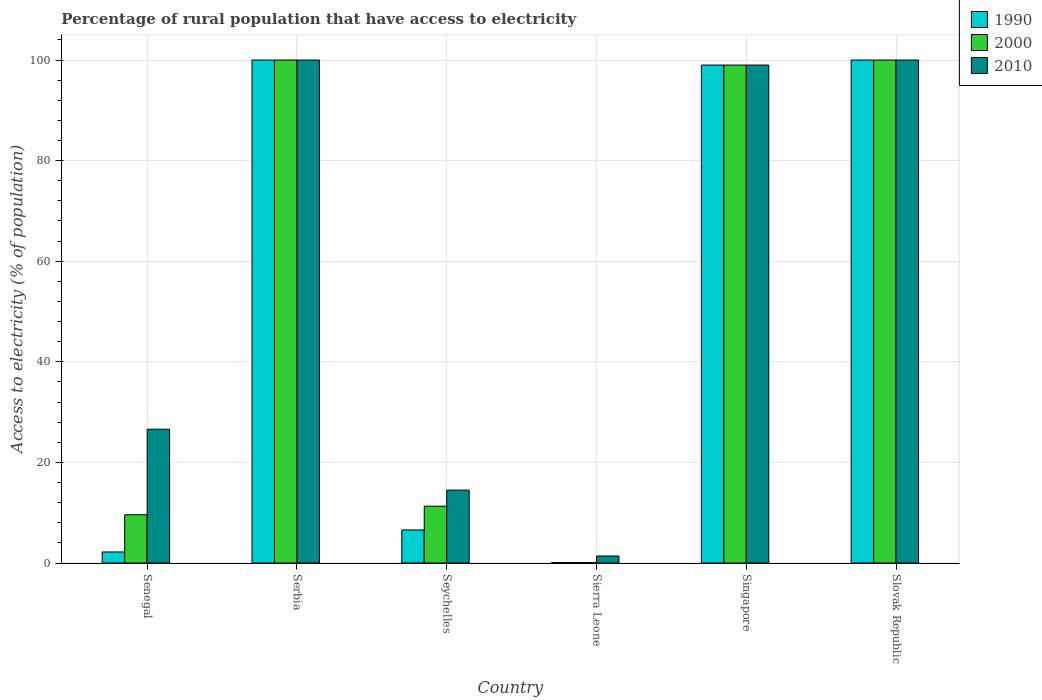How many different coloured bars are there?
Give a very brief answer. 3. What is the label of the 5th group of bars from the left?
Keep it short and to the point. Singapore. In how many cases, is the number of bars for a given country not equal to the number of legend labels?
Ensure brevity in your answer.  0. Across all countries, what is the maximum percentage of rural population that have access to electricity in 1990?
Offer a terse response. 100. In which country was the percentage of rural population that have access to electricity in 2000 maximum?
Provide a succinct answer. Serbia. In which country was the percentage of rural population that have access to electricity in 2010 minimum?
Make the answer very short. Sierra Leone. What is the total percentage of rural population that have access to electricity in 2010 in the graph?
Your answer should be very brief. 341.5. What is the difference between the percentage of rural population that have access to electricity in 2000 in Sierra Leone and that in Singapore?
Your answer should be very brief. -98.9. What is the difference between the percentage of rural population that have access to electricity in 2010 in Sierra Leone and the percentage of rural population that have access to electricity in 2000 in Singapore?
Your answer should be compact. -97.6. What is the average percentage of rural population that have access to electricity in 2000 per country?
Your answer should be compact. 53.33. What is the difference between the percentage of rural population that have access to electricity of/in 2000 and percentage of rural population that have access to electricity of/in 1990 in Senegal?
Keep it short and to the point. 7.4. What is the ratio of the percentage of rural population that have access to electricity in 2010 in Serbia to that in Sierra Leone?
Ensure brevity in your answer.  71.43. What is the difference between the highest and the lowest percentage of rural population that have access to electricity in 2010?
Provide a succinct answer. 98.6. Is the sum of the percentage of rural population that have access to electricity in 2010 in Seychelles and Slovak Republic greater than the maximum percentage of rural population that have access to electricity in 1990 across all countries?
Offer a very short reply. Yes. What does the 3rd bar from the right in Serbia represents?
Give a very brief answer. 1990. Are all the bars in the graph horizontal?
Make the answer very short. No. What is the difference between two consecutive major ticks on the Y-axis?
Offer a very short reply. 20. Does the graph contain any zero values?
Make the answer very short. No. Does the graph contain grids?
Offer a very short reply. Yes. How many legend labels are there?
Offer a terse response. 3. What is the title of the graph?
Make the answer very short. Percentage of rural population that have access to electricity. Does "1960" appear as one of the legend labels in the graph?
Ensure brevity in your answer.  No. What is the label or title of the Y-axis?
Provide a succinct answer. Access to electricity (% of population). What is the Access to electricity (% of population) in 2010 in Senegal?
Offer a very short reply. 26.6. What is the Access to electricity (% of population) in 2000 in Serbia?
Keep it short and to the point. 100. What is the Access to electricity (% of population) in 1990 in Seychelles?
Provide a short and direct response. 6.58. What is the Access to electricity (% of population) in 2000 in Seychelles?
Your response must be concise. 11.3. What is the Access to electricity (% of population) in 2010 in Seychelles?
Make the answer very short. 14.5. What is the Access to electricity (% of population) in 2000 in Sierra Leone?
Offer a terse response. 0.1. What is the Access to electricity (% of population) of 1990 in Singapore?
Offer a terse response. 99. What is the Access to electricity (% of population) of 2010 in Singapore?
Your response must be concise. 99. What is the Access to electricity (% of population) in 1990 in Slovak Republic?
Your response must be concise. 100. What is the Access to electricity (% of population) of 2000 in Slovak Republic?
Give a very brief answer. 100. Across all countries, what is the minimum Access to electricity (% of population) in 2000?
Ensure brevity in your answer.  0.1. Across all countries, what is the minimum Access to electricity (% of population) of 2010?
Your answer should be compact. 1.4. What is the total Access to electricity (% of population) in 1990 in the graph?
Make the answer very short. 307.88. What is the total Access to electricity (% of population) of 2000 in the graph?
Offer a terse response. 320. What is the total Access to electricity (% of population) of 2010 in the graph?
Keep it short and to the point. 341.5. What is the difference between the Access to electricity (% of population) of 1990 in Senegal and that in Serbia?
Make the answer very short. -97.8. What is the difference between the Access to electricity (% of population) in 2000 in Senegal and that in Serbia?
Your response must be concise. -90.4. What is the difference between the Access to electricity (% of population) in 2010 in Senegal and that in Serbia?
Provide a succinct answer. -73.4. What is the difference between the Access to electricity (% of population) in 1990 in Senegal and that in Seychelles?
Your answer should be very brief. -4.38. What is the difference between the Access to electricity (% of population) of 2000 in Senegal and that in Seychelles?
Your answer should be compact. -1.7. What is the difference between the Access to electricity (% of population) in 2010 in Senegal and that in Sierra Leone?
Give a very brief answer. 25.2. What is the difference between the Access to electricity (% of population) in 1990 in Senegal and that in Singapore?
Provide a short and direct response. -96.8. What is the difference between the Access to electricity (% of population) of 2000 in Senegal and that in Singapore?
Ensure brevity in your answer.  -89.4. What is the difference between the Access to electricity (% of population) in 2010 in Senegal and that in Singapore?
Keep it short and to the point. -72.4. What is the difference between the Access to electricity (% of population) in 1990 in Senegal and that in Slovak Republic?
Make the answer very short. -97.8. What is the difference between the Access to electricity (% of population) of 2000 in Senegal and that in Slovak Republic?
Offer a very short reply. -90.4. What is the difference between the Access to electricity (% of population) in 2010 in Senegal and that in Slovak Republic?
Give a very brief answer. -73.4. What is the difference between the Access to electricity (% of population) of 1990 in Serbia and that in Seychelles?
Offer a very short reply. 93.42. What is the difference between the Access to electricity (% of population) of 2000 in Serbia and that in Seychelles?
Keep it short and to the point. 88.7. What is the difference between the Access to electricity (% of population) in 2010 in Serbia and that in Seychelles?
Your answer should be compact. 85.5. What is the difference between the Access to electricity (% of population) in 1990 in Serbia and that in Sierra Leone?
Your answer should be very brief. 99.9. What is the difference between the Access to electricity (% of population) of 2000 in Serbia and that in Sierra Leone?
Make the answer very short. 99.9. What is the difference between the Access to electricity (% of population) of 2010 in Serbia and that in Sierra Leone?
Offer a terse response. 98.6. What is the difference between the Access to electricity (% of population) of 1990 in Serbia and that in Singapore?
Provide a short and direct response. 1. What is the difference between the Access to electricity (% of population) of 1990 in Serbia and that in Slovak Republic?
Provide a succinct answer. 0. What is the difference between the Access to electricity (% of population) of 2010 in Serbia and that in Slovak Republic?
Provide a short and direct response. 0. What is the difference between the Access to electricity (% of population) in 1990 in Seychelles and that in Sierra Leone?
Make the answer very short. 6.48. What is the difference between the Access to electricity (% of population) in 2000 in Seychelles and that in Sierra Leone?
Ensure brevity in your answer.  11.2. What is the difference between the Access to electricity (% of population) in 2010 in Seychelles and that in Sierra Leone?
Offer a very short reply. 13.1. What is the difference between the Access to electricity (% of population) in 1990 in Seychelles and that in Singapore?
Offer a very short reply. -92.42. What is the difference between the Access to electricity (% of population) in 2000 in Seychelles and that in Singapore?
Your response must be concise. -87.7. What is the difference between the Access to electricity (% of population) in 2010 in Seychelles and that in Singapore?
Offer a terse response. -84.5. What is the difference between the Access to electricity (% of population) in 1990 in Seychelles and that in Slovak Republic?
Ensure brevity in your answer.  -93.42. What is the difference between the Access to electricity (% of population) of 2000 in Seychelles and that in Slovak Republic?
Make the answer very short. -88.7. What is the difference between the Access to electricity (% of population) in 2010 in Seychelles and that in Slovak Republic?
Offer a terse response. -85.5. What is the difference between the Access to electricity (% of population) in 1990 in Sierra Leone and that in Singapore?
Your answer should be very brief. -98.9. What is the difference between the Access to electricity (% of population) in 2000 in Sierra Leone and that in Singapore?
Your response must be concise. -98.9. What is the difference between the Access to electricity (% of population) in 2010 in Sierra Leone and that in Singapore?
Offer a terse response. -97.6. What is the difference between the Access to electricity (% of population) in 1990 in Sierra Leone and that in Slovak Republic?
Give a very brief answer. -99.9. What is the difference between the Access to electricity (% of population) of 2000 in Sierra Leone and that in Slovak Republic?
Provide a short and direct response. -99.9. What is the difference between the Access to electricity (% of population) of 2010 in Sierra Leone and that in Slovak Republic?
Provide a succinct answer. -98.6. What is the difference between the Access to electricity (% of population) in 1990 in Singapore and that in Slovak Republic?
Keep it short and to the point. -1. What is the difference between the Access to electricity (% of population) of 1990 in Senegal and the Access to electricity (% of population) of 2000 in Serbia?
Offer a terse response. -97.8. What is the difference between the Access to electricity (% of population) in 1990 in Senegal and the Access to electricity (% of population) in 2010 in Serbia?
Your response must be concise. -97.8. What is the difference between the Access to electricity (% of population) in 2000 in Senegal and the Access to electricity (% of population) in 2010 in Serbia?
Provide a short and direct response. -90.4. What is the difference between the Access to electricity (% of population) of 1990 in Senegal and the Access to electricity (% of population) of 2000 in Seychelles?
Offer a terse response. -9.1. What is the difference between the Access to electricity (% of population) of 1990 in Senegal and the Access to electricity (% of population) of 2010 in Seychelles?
Your response must be concise. -12.3. What is the difference between the Access to electricity (% of population) in 1990 in Senegal and the Access to electricity (% of population) in 2000 in Sierra Leone?
Offer a terse response. 2.1. What is the difference between the Access to electricity (% of population) of 1990 in Senegal and the Access to electricity (% of population) of 2010 in Sierra Leone?
Provide a succinct answer. 0.8. What is the difference between the Access to electricity (% of population) in 2000 in Senegal and the Access to electricity (% of population) in 2010 in Sierra Leone?
Your answer should be compact. 8.2. What is the difference between the Access to electricity (% of population) in 1990 in Senegal and the Access to electricity (% of population) in 2000 in Singapore?
Provide a succinct answer. -96.8. What is the difference between the Access to electricity (% of population) in 1990 in Senegal and the Access to electricity (% of population) in 2010 in Singapore?
Give a very brief answer. -96.8. What is the difference between the Access to electricity (% of population) in 2000 in Senegal and the Access to electricity (% of population) in 2010 in Singapore?
Keep it short and to the point. -89.4. What is the difference between the Access to electricity (% of population) of 1990 in Senegal and the Access to electricity (% of population) of 2000 in Slovak Republic?
Give a very brief answer. -97.8. What is the difference between the Access to electricity (% of population) of 1990 in Senegal and the Access to electricity (% of population) of 2010 in Slovak Republic?
Ensure brevity in your answer.  -97.8. What is the difference between the Access to electricity (% of population) in 2000 in Senegal and the Access to electricity (% of population) in 2010 in Slovak Republic?
Offer a terse response. -90.4. What is the difference between the Access to electricity (% of population) in 1990 in Serbia and the Access to electricity (% of population) in 2000 in Seychelles?
Your answer should be very brief. 88.7. What is the difference between the Access to electricity (% of population) in 1990 in Serbia and the Access to electricity (% of population) in 2010 in Seychelles?
Make the answer very short. 85.5. What is the difference between the Access to electricity (% of population) in 2000 in Serbia and the Access to electricity (% of population) in 2010 in Seychelles?
Your response must be concise. 85.5. What is the difference between the Access to electricity (% of population) in 1990 in Serbia and the Access to electricity (% of population) in 2000 in Sierra Leone?
Your answer should be very brief. 99.9. What is the difference between the Access to electricity (% of population) of 1990 in Serbia and the Access to electricity (% of population) of 2010 in Sierra Leone?
Keep it short and to the point. 98.6. What is the difference between the Access to electricity (% of population) in 2000 in Serbia and the Access to electricity (% of population) in 2010 in Sierra Leone?
Offer a very short reply. 98.6. What is the difference between the Access to electricity (% of population) of 1990 in Serbia and the Access to electricity (% of population) of 2000 in Singapore?
Give a very brief answer. 1. What is the difference between the Access to electricity (% of population) in 1990 in Serbia and the Access to electricity (% of population) in 2010 in Slovak Republic?
Your response must be concise. 0. What is the difference between the Access to electricity (% of population) of 2000 in Serbia and the Access to electricity (% of population) of 2010 in Slovak Republic?
Your answer should be very brief. 0. What is the difference between the Access to electricity (% of population) in 1990 in Seychelles and the Access to electricity (% of population) in 2000 in Sierra Leone?
Offer a very short reply. 6.48. What is the difference between the Access to electricity (% of population) of 1990 in Seychelles and the Access to electricity (% of population) of 2010 in Sierra Leone?
Offer a very short reply. 5.18. What is the difference between the Access to electricity (% of population) of 2000 in Seychelles and the Access to electricity (% of population) of 2010 in Sierra Leone?
Give a very brief answer. 9.9. What is the difference between the Access to electricity (% of population) in 1990 in Seychelles and the Access to electricity (% of population) in 2000 in Singapore?
Ensure brevity in your answer.  -92.42. What is the difference between the Access to electricity (% of population) of 1990 in Seychelles and the Access to electricity (% of population) of 2010 in Singapore?
Ensure brevity in your answer.  -92.42. What is the difference between the Access to electricity (% of population) of 2000 in Seychelles and the Access to electricity (% of population) of 2010 in Singapore?
Keep it short and to the point. -87.7. What is the difference between the Access to electricity (% of population) of 1990 in Seychelles and the Access to electricity (% of population) of 2000 in Slovak Republic?
Give a very brief answer. -93.42. What is the difference between the Access to electricity (% of population) of 1990 in Seychelles and the Access to electricity (% of population) of 2010 in Slovak Republic?
Ensure brevity in your answer.  -93.42. What is the difference between the Access to electricity (% of population) in 2000 in Seychelles and the Access to electricity (% of population) in 2010 in Slovak Republic?
Ensure brevity in your answer.  -88.7. What is the difference between the Access to electricity (% of population) in 1990 in Sierra Leone and the Access to electricity (% of population) in 2000 in Singapore?
Ensure brevity in your answer.  -98.9. What is the difference between the Access to electricity (% of population) in 1990 in Sierra Leone and the Access to electricity (% of population) in 2010 in Singapore?
Your answer should be compact. -98.9. What is the difference between the Access to electricity (% of population) in 2000 in Sierra Leone and the Access to electricity (% of population) in 2010 in Singapore?
Make the answer very short. -98.9. What is the difference between the Access to electricity (% of population) of 1990 in Sierra Leone and the Access to electricity (% of population) of 2000 in Slovak Republic?
Your answer should be very brief. -99.9. What is the difference between the Access to electricity (% of population) of 1990 in Sierra Leone and the Access to electricity (% of population) of 2010 in Slovak Republic?
Ensure brevity in your answer.  -99.9. What is the difference between the Access to electricity (% of population) of 2000 in Sierra Leone and the Access to electricity (% of population) of 2010 in Slovak Republic?
Make the answer very short. -99.9. What is the difference between the Access to electricity (% of population) of 1990 in Singapore and the Access to electricity (% of population) of 2000 in Slovak Republic?
Offer a very short reply. -1. What is the average Access to electricity (% of population) in 1990 per country?
Provide a short and direct response. 51.31. What is the average Access to electricity (% of population) of 2000 per country?
Your answer should be compact. 53.33. What is the average Access to electricity (% of population) in 2010 per country?
Make the answer very short. 56.92. What is the difference between the Access to electricity (% of population) of 1990 and Access to electricity (% of population) of 2000 in Senegal?
Provide a succinct answer. -7.4. What is the difference between the Access to electricity (% of population) in 1990 and Access to electricity (% of population) in 2010 in Senegal?
Your response must be concise. -24.4. What is the difference between the Access to electricity (% of population) of 2000 and Access to electricity (% of population) of 2010 in Senegal?
Your response must be concise. -17. What is the difference between the Access to electricity (% of population) of 1990 and Access to electricity (% of population) of 2010 in Serbia?
Provide a short and direct response. 0. What is the difference between the Access to electricity (% of population) in 1990 and Access to electricity (% of population) in 2000 in Seychelles?
Give a very brief answer. -4.72. What is the difference between the Access to electricity (% of population) in 1990 and Access to electricity (% of population) in 2010 in Seychelles?
Provide a short and direct response. -7.92. What is the difference between the Access to electricity (% of population) of 2000 and Access to electricity (% of population) of 2010 in Seychelles?
Give a very brief answer. -3.2. What is the difference between the Access to electricity (% of population) of 1990 and Access to electricity (% of population) of 2000 in Sierra Leone?
Keep it short and to the point. 0. What is the difference between the Access to electricity (% of population) of 2000 and Access to electricity (% of population) of 2010 in Singapore?
Your answer should be very brief. 0. What is the difference between the Access to electricity (% of population) in 1990 and Access to electricity (% of population) in 2010 in Slovak Republic?
Provide a short and direct response. 0. What is the ratio of the Access to electricity (% of population) in 1990 in Senegal to that in Serbia?
Your response must be concise. 0.02. What is the ratio of the Access to electricity (% of population) in 2000 in Senegal to that in Serbia?
Provide a short and direct response. 0.1. What is the ratio of the Access to electricity (% of population) of 2010 in Senegal to that in Serbia?
Your answer should be very brief. 0.27. What is the ratio of the Access to electricity (% of population) of 1990 in Senegal to that in Seychelles?
Your answer should be compact. 0.33. What is the ratio of the Access to electricity (% of population) in 2000 in Senegal to that in Seychelles?
Your response must be concise. 0.85. What is the ratio of the Access to electricity (% of population) in 2010 in Senegal to that in Seychelles?
Ensure brevity in your answer.  1.83. What is the ratio of the Access to electricity (% of population) in 1990 in Senegal to that in Sierra Leone?
Your answer should be very brief. 22. What is the ratio of the Access to electricity (% of population) of 2000 in Senegal to that in Sierra Leone?
Offer a very short reply. 96. What is the ratio of the Access to electricity (% of population) of 1990 in Senegal to that in Singapore?
Ensure brevity in your answer.  0.02. What is the ratio of the Access to electricity (% of population) of 2000 in Senegal to that in Singapore?
Offer a terse response. 0.1. What is the ratio of the Access to electricity (% of population) in 2010 in Senegal to that in Singapore?
Ensure brevity in your answer.  0.27. What is the ratio of the Access to electricity (% of population) of 1990 in Senegal to that in Slovak Republic?
Provide a short and direct response. 0.02. What is the ratio of the Access to electricity (% of population) in 2000 in Senegal to that in Slovak Republic?
Keep it short and to the point. 0.1. What is the ratio of the Access to electricity (% of population) in 2010 in Senegal to that in Slovak Republic?
Provide a succinct answer. 0.27. What is the ratio of the Access to electricity (% of population) in 1990 in Serbia to that in Seychelles?
Provide a short and direct response. 15.2. What is the ratio of the Access to electricity (% of population) in 2000 in Serbia to that in Seychelles?
Provide a succinct answer. 8.85. What is the ratio of the Access to electricity (% of population) of 2010 in Serbia to that in Seychelles?
Keep it short and to the point. 6.9. What is the ratio of the Access to electricity (% of population) of 2000 in Serbia to that in Sierra Leone?
Offer a very short reply. 1000. What is the ratio of the Access to electricity (% of population) of 2010 in Serbia to that in Sierra Leone?
Provide a short and direct response. 71.43. What is the ratio of the Access to electricity (% of population) in 1990 in Serbia to that in Slovak Republic?
Your answer should be compact. 1. What is the ratio of the Access to electricity (% of population) in 2010 in Serbia to that in Slovak Republic?
Your answer should be compact. 1. What is the ratio of the Access to electricity (% of population) of 1990 in Seychelles to that in Sierra Leone?
Your response must be concise. 65.79. What is the ratio of the Access to electricity (% of population) in 2000 in Seychelles to that in Sierra Leone?
Your answer should be compact. 113.02. What is the ratio of the Access to electricity (% of population) of 2010 in Seychelles to that in Sierra Leone?
Provide a short and direct response. 10.36. What is the ratio of the Access to electricity (% of population) of 1990 in Seychelles to that in Singapore?
Make the answer very short. 0.07. What is the ratio of the Access to electricity (% of population) in 2000 in Seychelles to that in Singapore?
Your answer should be compact. 0.11. What is the ratio of the Access to electricity (% of population) in 2010 in Seychelles to that in Singapore?
Offer a terse response. 0.15. What is the ratio of the Access to electricity (% of population) in 1990 in Seychelles to that in Slovak Republic?
Your answer should be compact. 0.07. What is the ratio of the Access to electricity (% of population) of 2000 in Seychelles to that in Slovak Republic?
Provide a succinct answer. 0.11. What is the ratio of the Access to electricity (% of population) in 2010 in Seychelles to that in Slovak Republic?
Offer a very short reply. 0.14. What is the ratio of the Access to electricity (% of population) of 2000 in Sierra Leone to that in Singapore?
Your answer should be compact. 0. What is the ratio of the Access to electricity (% of population) of 2010 in Sierra Leone to that in Singapore?
Make the answer very short. 0.01. What is the ratio of the Access to electricity (% of population) in 1990 in Sierra Leone to that in Slovak Republic?
Your response must be concise. 0. What is the ratio of the Access to electricity (% of population) in 2010 in Sierra Leone to that in Slovak Republic?
Offer a terse response. 0.01. What is the ratio of the Access to electricity (% of population) of 1990 in Singapore to that in Slovak Republic?
Provide a succinct answer. 0.99. What is the ratio of the Access to electricity (% of population) of 2000 in Singapore to that in Slovak Republic?
Provide a short and direct response. 0.99. What is the ratio of the Access to electricity (% of population) in 2010 in Singapore to that in Slovak Republic?
Provide a short and direct response. 0.99. What is the difference between the highest and the second highest Access to electricity (% of population) in 1990?
Your answer should be very brief. 0. What is the difference between the highest and the second highest Access to electricity (% of population) in 2000?
Make the answer very short. 0. What is the difference between the highest and the second highest Access to electricity (% of population) of 2010?
Your answer should be very brief. 0. What is the difference between the highest and the lowest Access to electricity (% of population) of 1990?
Give a very brief answer. 99.9. What is the difference between the highest and the lowest Access to electricity (% of population) of 2000?
Keep it short and to the point. 99.9. What is the difference between the highest and the lowest Access to electricity (% of population) in 2010?
Your answer should be compact. 98.6. 